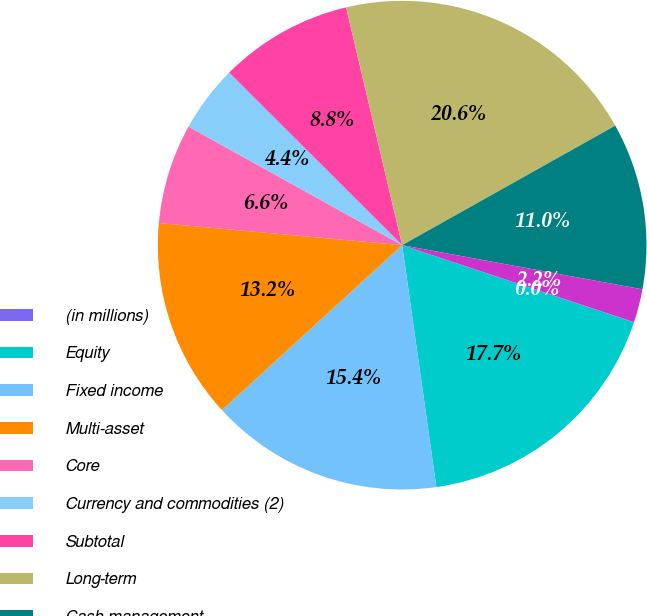Convert chart to OTSL. <chart><loc_0><loc_0><loc_500><loc_500><pie_chart><fcel>(in millions)<fcel>Equity<fcel>Fixed income<fcel>Multi-asset<fcel>Core<fcel>Currency and commodities (2)<fcel>Subtotal<fcel>Long-term<fcel>Cash management<fcel>Advisory (1)<nl><fcel>0.01%<fcel>17.65%<fcel>15.44%<fcel>13.24%<fcel>6.62%<fcel>4.42%<fcel>8.83%<fcel>20.55%<fcel>11.03%<fcel>2.21%<nl></chart> 